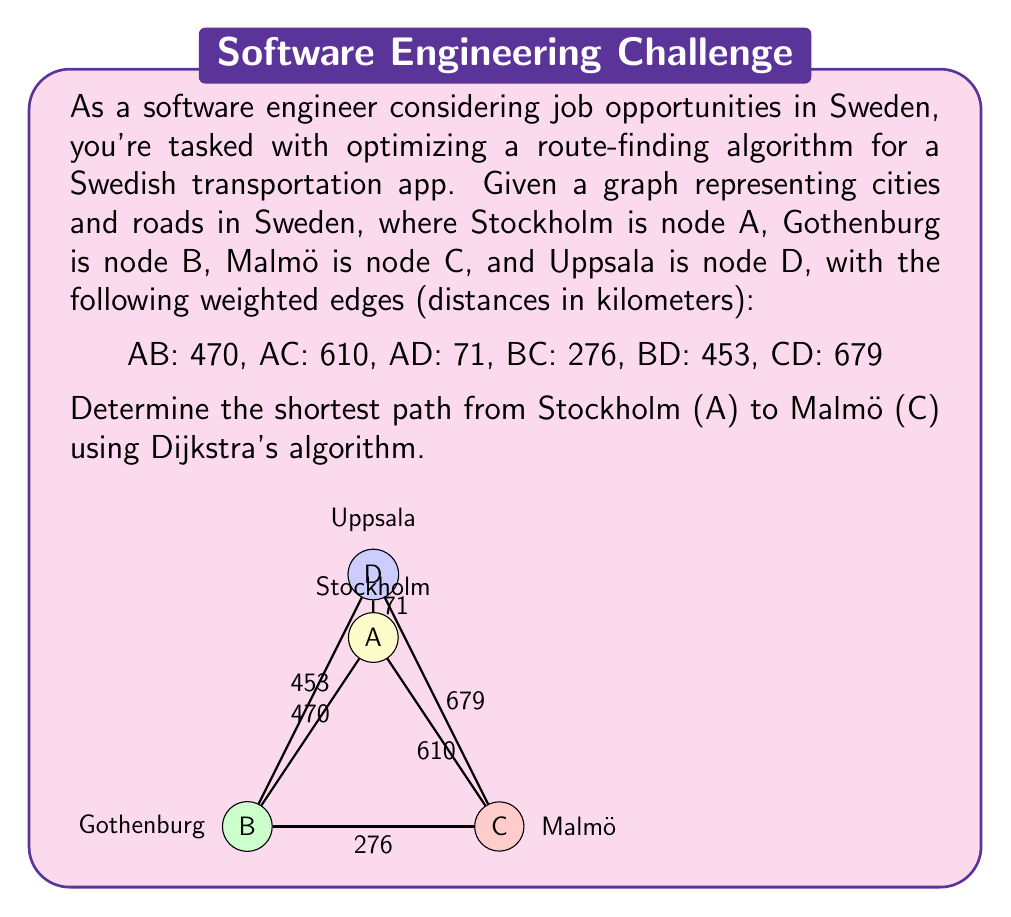Give your solution to this math problem. To solve this problem using Dijkstra's algorithm, we'll follow these steps:

1. Initialize:
   - Set distance to A (Stockholm) as 0 and all others as infinity.
   - Set all nodes as unvisited.
   - Set A as the current node.

2. For the current node, consider all unvisited neighbors and calculate their tentative distances.
   - If the calculated distance is less than the previously recorded distance, update it.

3. Mark the current node as visited and remove it from the unvisited set.

4. If the destination node (C) has been marked visited, we're done.
   Otherwise, select the unvisited node with the smallest tentative distance and set it as the new current node.

5. Repeat steps 2-4 until we reach the destination.

Let's apply the algorithm:

Step 1: Initialize
- A: 0, B: ∞, C: ∞, D: ∞
- Unvisited: {A, B, C, D}
- Current: A

Step 2-3: Process A
- Update neighbors: B: 470, C: 610, D: 71
- Mark A as visited
- Unvisited: {B, C, D}

Step 4: Select D (smallest distance)

Step 2-3: Process D
- Update neighbors: B: min(470, 71 + 453) = 470, C: min(610, 71 + 679) = 610
- Mark D as visited
- Unvisited: {B, C}

Step 4: Select B (smallest distance)

Step 2-3: Process B
- Update neighbors: C: min(610, 470 + 276) = 610
- Mark B as visited
- Unvisited: {C}

Step 4: Select C (only remaining node)

The algorithm terminates as we've reached the destination C.

The shortest path from A to C is A → C with a distance of 610 km.
Answer: A → C, 610 km 